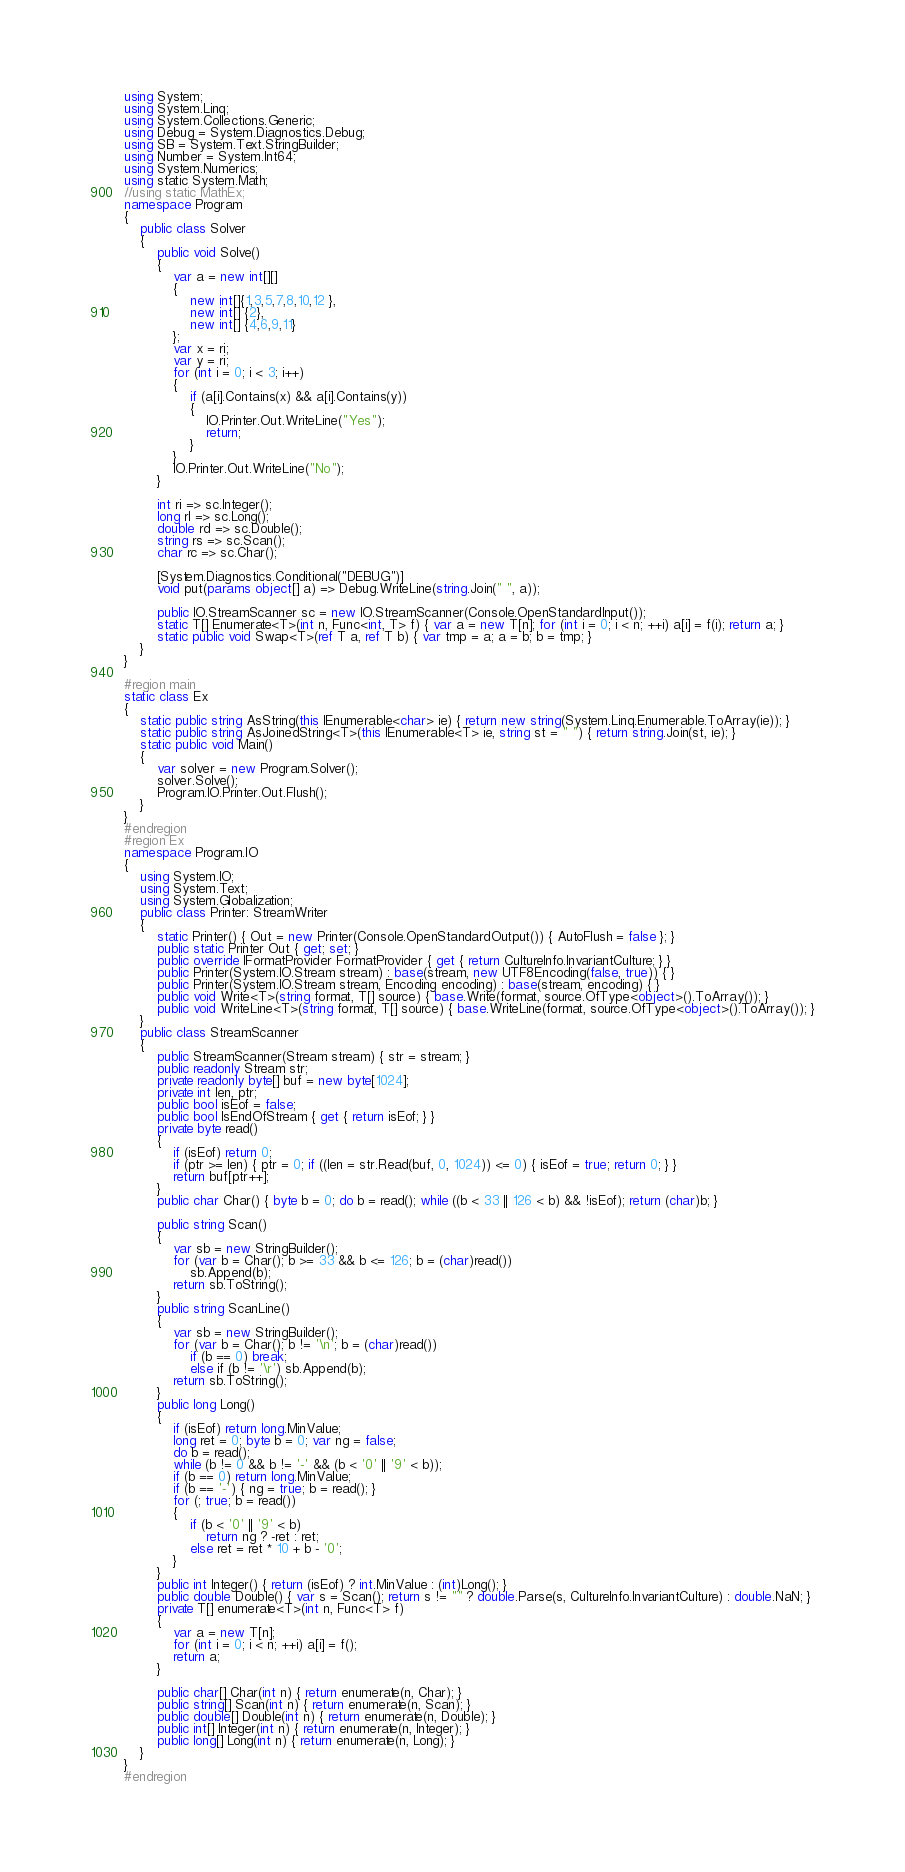<code> <loc_0><loc_0><loc_500><loc_500><_C#_>using System;
using System.Linq;
using System.Collections.Generic;
using Debug = System.Diagnostics.Debug;
using SB = System.Text.StringBuilder;
using Number = System.Int64;
using System.Numerics;
using static System.Math;
//using static MathEx;
namespace Program
{
    public class Solver
    {
        public void Solve()
        {
            var a = new int[][]
            {
                new int[]{1,3,5,7,8,10,12 },
                new int[] {2},
                new int[] {4,6,9,11}
            };
            var x = ri;
            var y = ri;
            for (int i = 0; i < 3; i++)
            {
                if (a[i].Contains(x) && a[i].Contains(y))
                {
                    IO.Printer.Out.WriteLine("Yes");
                    return;
                }
            }
            IO.Printer.Out.WriteLine("No");
        }

        int ri => sc.Integer();
        long rl => sc.Long();
        double rd => sc.Double();
        string rs => sc.Scan();
        char rc => sc.Char();

        [System.Diagnostics.Conditional("DEBUG")]
        void put(params object[] a) => Debug.WriteLine(string.Join(" ", a));

        public IO.StreamScanner sc = new IO.StreamScanner(Console.OpenStandardInput());
        static T[] Enumerate<T>(int n, Func<int, T> f) { var a = new T[n]; for (int i = 0; i < n; ++i) a[i] = f(i); return a; }
        static public void Swap<T>(ref T a, ref T b) { var tmp = a; a = b; b = tmp; }
    }
}

#region main
static class Ex
{
    static public string AsString(this IEnumerable<char> ie) { return new string(System.Linq.Enumerable.ToArray(ie)); }
    static public string AsJoinedString<T>(this IEnumerable<T> ie, string st = " ") { return string.Join(st, ie); }
    static public void Main()
    {
        var solver = new Program.Solver();
        solver.Solve();
        Program.IO.Printer.Out.Flush();
    }
}
#endregion
#region Ex
namespace Program.IO
{
    using System.IO;
    using System.Text;
    using System.Globalization;
    public class Printer: StreamWriter
    {
        static Printer() { Out = new Printer(Console.OpenStandardOutput()) { AutoFlush = false }; }
        public static Printer Out { get; set; }
        public override IFormatProvider FormatProvider { get { return CultureInfo.InvariantCulture; } }
        public Printer(System.IO.Stream stream) : base(stream, new UTF8Encoding(false, true)) { }
        public Printer(System.IO.Stream stream, Encoding encoding) : base(stream, encoding) { }
        public void Write<T>(string format, T[] source) { base.Write(format, source.OfType<object>().ToArray()); }
        public void WriteLine<T>(string format, T[] source) { base.WriteLine(format, source.OfType<object>().ToArray()); }
    }
    public class StreamScanner
    {
        public StreamScanner(Stream stream) { str = stream; }
        public readonly Stream str;
        private readonly byte[] buf = new byte[1024];
        private int len, ptr;
        public bool isEof = false;
        public bool IsEndOfStream { get { return isEof; } }
        private byte read()
        {
            if (isEof) return 0;
            if (ptr >= len) { ptr = 0; if ((len = str.Read(buf, 0, 1024)) <= 0) { isEof = true; return 0; } }
            return buf[ptr++];
        }
        public char Char() { byte b = 0; do b = read(); while ((b < 33 || 126 < b) && !isEof); return (char)b; }

        public string Scan()
        {
            var sb = new StringBuilder();
            for (var b = Char(); b >= 33 && b <= 126; b = (char)read())
                sb.Append(b);
            return sb.ToString();
        }
        public string ScanLine()
        {
            var sb = new StringBuilder();
            for (var b = Char(); b != '\n'; b = (char)read())
                if (b == 0) break;
                else if (b != '\r') sb.Append(b);
            return sb.ToString();
        }
        public long Long()
        {
            if (isEof) return long.MinValue;
            long ret = 0; byte b = 0; var ng = false;
            do b = read();
            while (b != 0 && b != '-' && (b < '0' || '9' < b));
            if (b == 0) return long.MinValue;
            if (b == '-') { ng = true; b = read(); }
            for (; true; b = read())
            {
                if (b < '0' || '9' < b)
                    return ng ? -ret : ret;
                else ret = ret * 10 + b - '0';
            }
        }
        public int Integer() { return (isEof) ? int.MinValue : (int)Long(); }
        public double Double() { var s = Scan(); return s != "" ? double.Parse(s, CultureInfo.InvariantCulture) : double.NaN; }
        private T[] enumerate<T>(int n, Func<T> f)
        {
            var a = new T[n];
            for (int i = 0; i < n; ++i) a[i] = f();
            return a;
        }

        public char[] Char(int n) { return enumerate(n, Char); }
        public string[] Scan(int n) { return enumerate(n, Scan); }
        public double[] Double(int n) { return enumerate(n, Double); }
        public int[] Integer(int n) { return enumerate(n, Integer); }
        public long[] Long(int n) { return enumerate(n, Long); }
    }
}
#endregion
</code> 